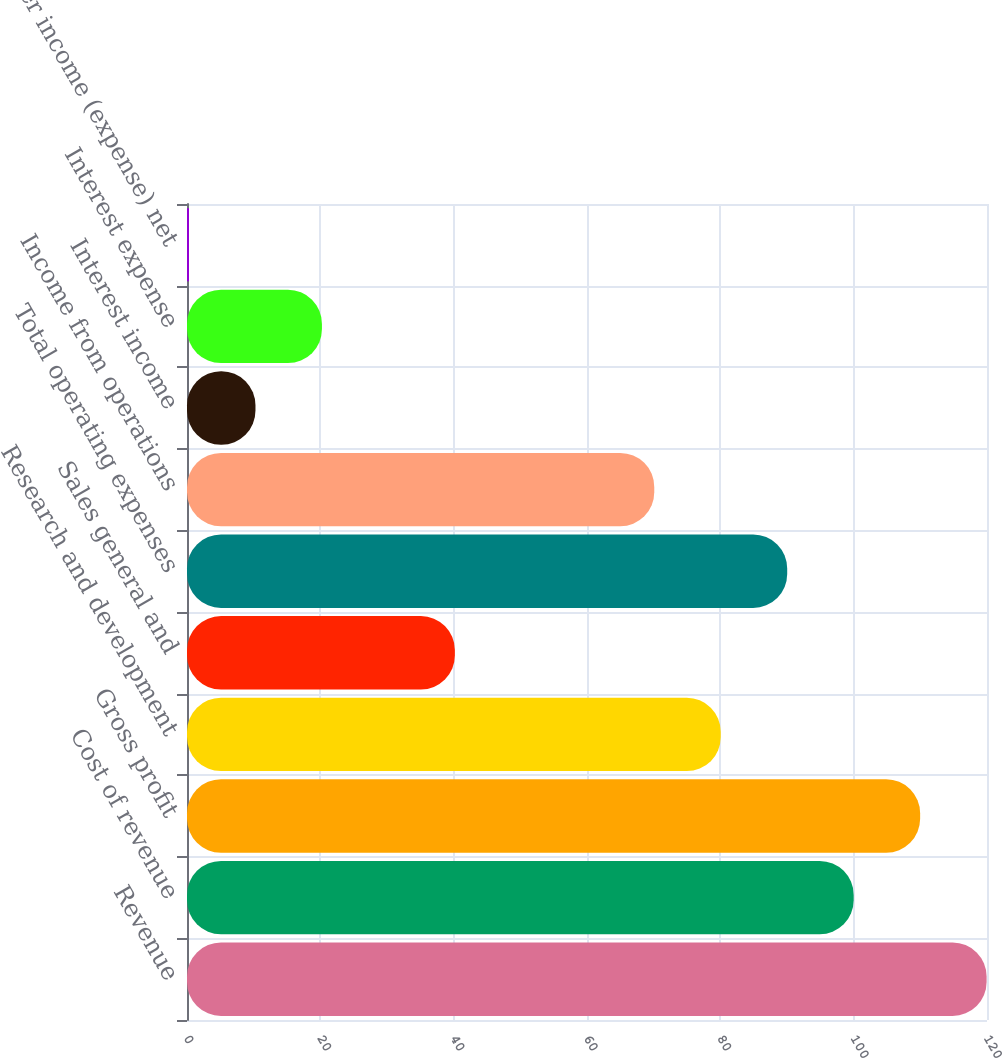Convert chart to OTSL. <chart><loc_0><loc_0><loc_500><loc_500><bar_chart><fcel>Revenue<fcel>Cost of revenue<fcel>Gross profit<fcel>Research and development<fcel>Sales general and<fcel>Total operating expenses<fcel>Income from operations<fcel>Interest income<fcel>Interest expense<fcel>Other income (expense) net<nl><fcel>119.94<fcel>100<fcel>109.97<fcel>80.06<fcel>40.18<fcel>90.03<fcel>70.09<fcel>10.27<fcel>20.24<fcel>0.3<nl></chart> 